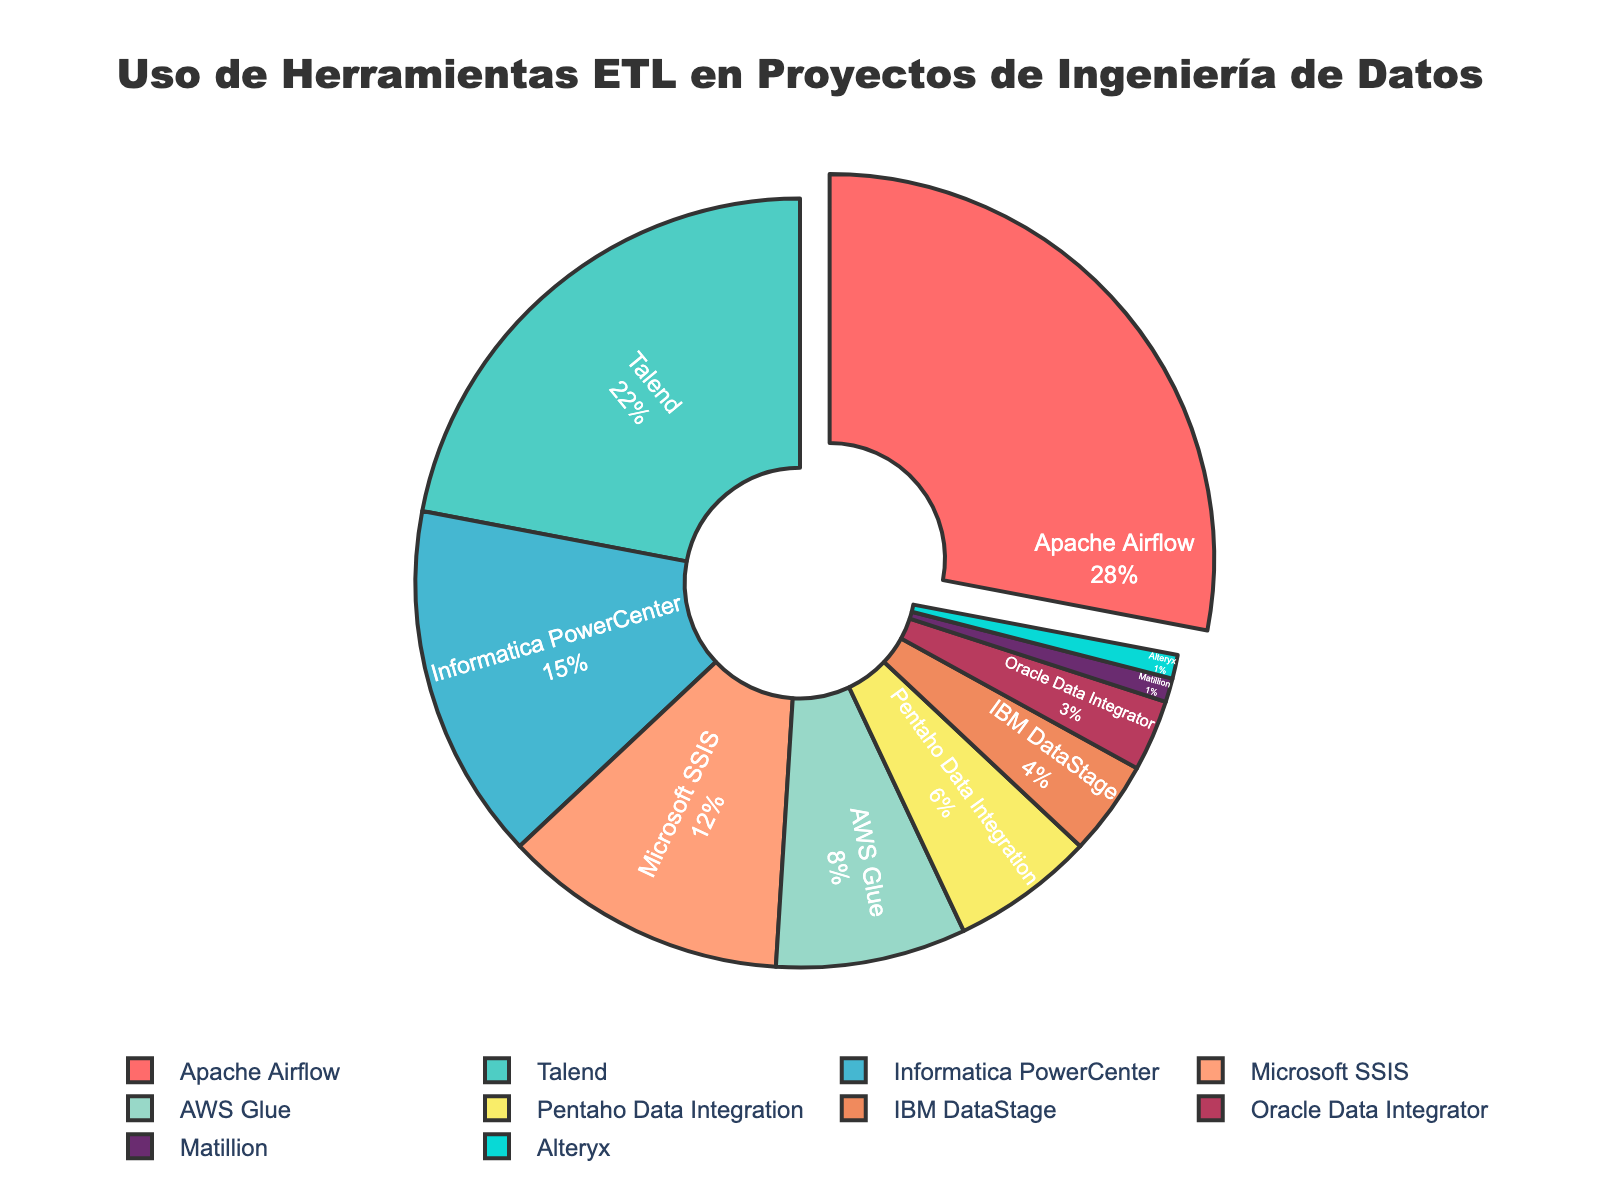¿Cuáles son las dos herramientas ETL más usadas en proyectos de ingeniería de datos? Primero, observa todas las secciones del gráfico y encuentra las etiquetas con los porcentajes más altos. Las dos herramientas con los porcentajes de uso más altos son Apache Airflow (28%) y Talend (22%).
Answer: Apache Airflow y Talend ¿Cuál es el porcentaje de uso combinado de AWS Glue y IBM DataStage? Suma los porcentajes de uso de AWS Glue (8%) y IBM DataStage (4%). La suma es 8 + 4 = 12.
Answer: 12% ¿Cuántas herramientas ETL tienen un uso menor o igual al 5%? Observa las secciones y comprueba los porcentajes de uso. Las herramientas ETL con un uso menor o igual al 5% son IBM DataStage (4%), Oracle Data Integrator (3%), Matillion (1%) y Alteryx (1%). Lo que suma un total de 4 herramientas.
Answer: 4 ¿Cuál es la diferencia en porcentaje de uso entre Apache Airflow y Microsoft SSIS? Resta el porcentaje de uso de Microsoft SSIS (12%) al de Apache Airflow (28%). La diferencia es 28 - 12 = 16.
Answer: 16% ¿Cuáles son las herramientas ETL con un porcentaje de uso mayor que Pentaho Data Integration pero menor que Talend? Observa los porcentajes de uso de las herramientas. Talend tiene 22% y Pentaho Data Integration tiene 6%. Las herramientas con un uso entre estos valores son Informatica PowerCenter (15%) y Microsoft SSIS (12%).
Answer: Informatica PowerCenter y Microsoft SSIS ¿Qué porcentaje del gráfico representa Alteryx y Matillion juntos? Suma los porcentajes de uso de Alteryx (1%) y Matillion (1%). La suma es 1 + 1 = 2.
Answer: 2% ¿Cuál es la herramienta ETL con el porcentaje de uso más bajo y de qué color está representada en el gráfico? Busca la sección con el porcentaje más bajo, que es Alteryx (1%). Observa el color de esa sección en el gráfico. Alteryx está representada por el color azul claro.
Answer: Alteryx, azul claro ¿Qué herramienta ETL tiene el tercer porcentaje de uso más alto y qué porcentaje es ese? Ordena los porcentajes de uso de mayor a menor. El tercer porcentaje más alto después de Apache Airflow (28%) y Talend (22%) es de Informatica PowerCenter con un 15%.
Answer: Informatica PowerCenter, 15% ¿Cuál es la diferencia en porcentaje de uso entre Talend y la suma de AWS Glue y Pentaho Data Integration? Suma los porcentajes de AWS Glue (8%) y Pentaho Data Integration (6%), que dan 14%. Luego resta este valor al porcentaje de Talend (22%). La diferencia es 22 - 14 = 8.
Answer: 8% ¿Qué porcentaje total ocupan las herramientas ETL que tienen un uso menor al 10%? Suma los porcentajes de AWS Glue (8%), Pentaho Data Integration (6%), IBM DataStage (4%), Oracle Data Integrator (3%), Matillion (1%) y Alteryx (1%). La suma da 8 + 6 + 4 + 3 + 1 + 1 = 23%.
Answer: 23% 